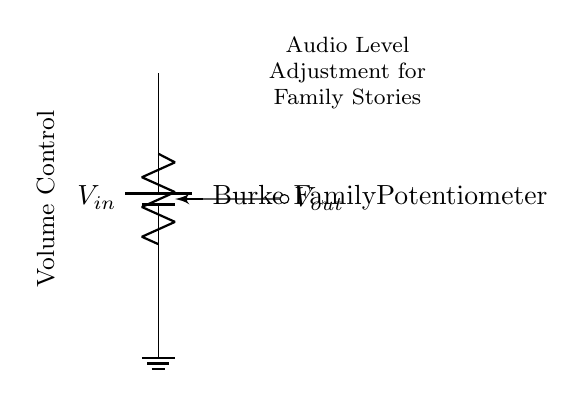What is the input voltage? The circuit does not specify a numerical value for the input voltage, but it is labeled as V-in.
Answer: V-in What component is used for volume control? The circuit shows a potentiometer, which is specifically labeled as the Burke Family Potentiometer. Potentiometers are commonly used for volume control.
Answer: Potentiometer What is the output voltage reference? The output voltage is taken from the wiper of the potentiometer, which is connected to the output node. The circuit shows this connection as V-out.
Answer: V-out What type of circuit is this? This circuit is a voltage divider, as it consists of a potentiometer connected in series with a voltage source to divide the input voltage for volume control.
Answer: Voltage divider How does adjusting the potentiometer affect voltage? Adjusting the potentiometer changes its resistance, which affects the division of voltage between its terminals, thus varying the output voltage V-out for audio levels.
Answer: Changes output voltage 